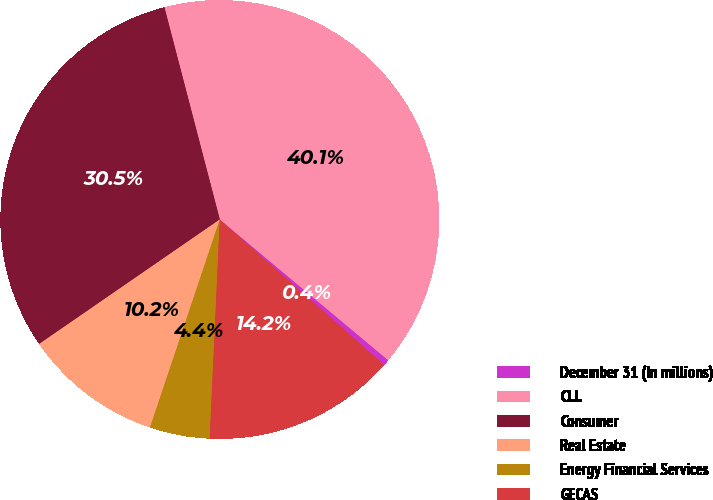Convert chart. <chart><loc_0><loc_0><loc_500><loc_500><pie_chart><fcel>December 31 (In millions)<fcel>CLL<fcel>Consumer<fcel>Real Estate<fcel>Energy Financial Services<fcel>GECAS<nl><fcel>0.45%<fcel>40.15%<fcel>30.55%<fcel>10.24%<fcel>4.42%<fcel>14.21%<nl></chart> 